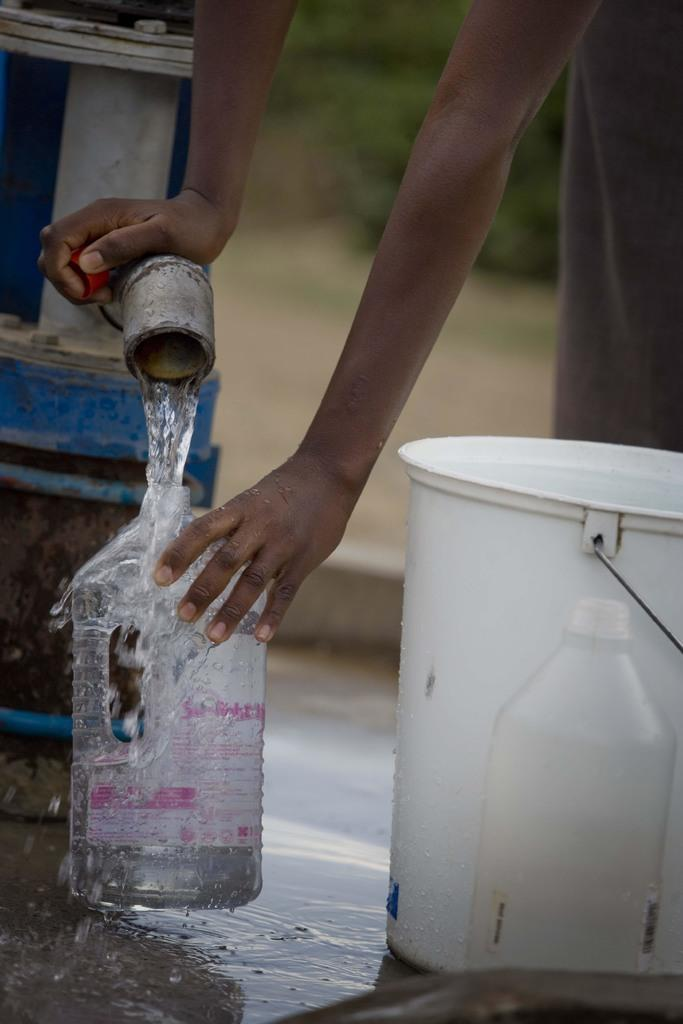Who is the person in the image? There is a man in the image. What is the man doing in the image? The man is filling a water bottle. How is the water bottle being filled? The water bottle is being filled from a pipe. What other objects can be seen in the image? There is a bucket and a bottle on the side in the image. What type of nose can be seen on the man in the image? There is no nose visible on the man in the image, as the focus is on his actions of filling a water bottle. --- 